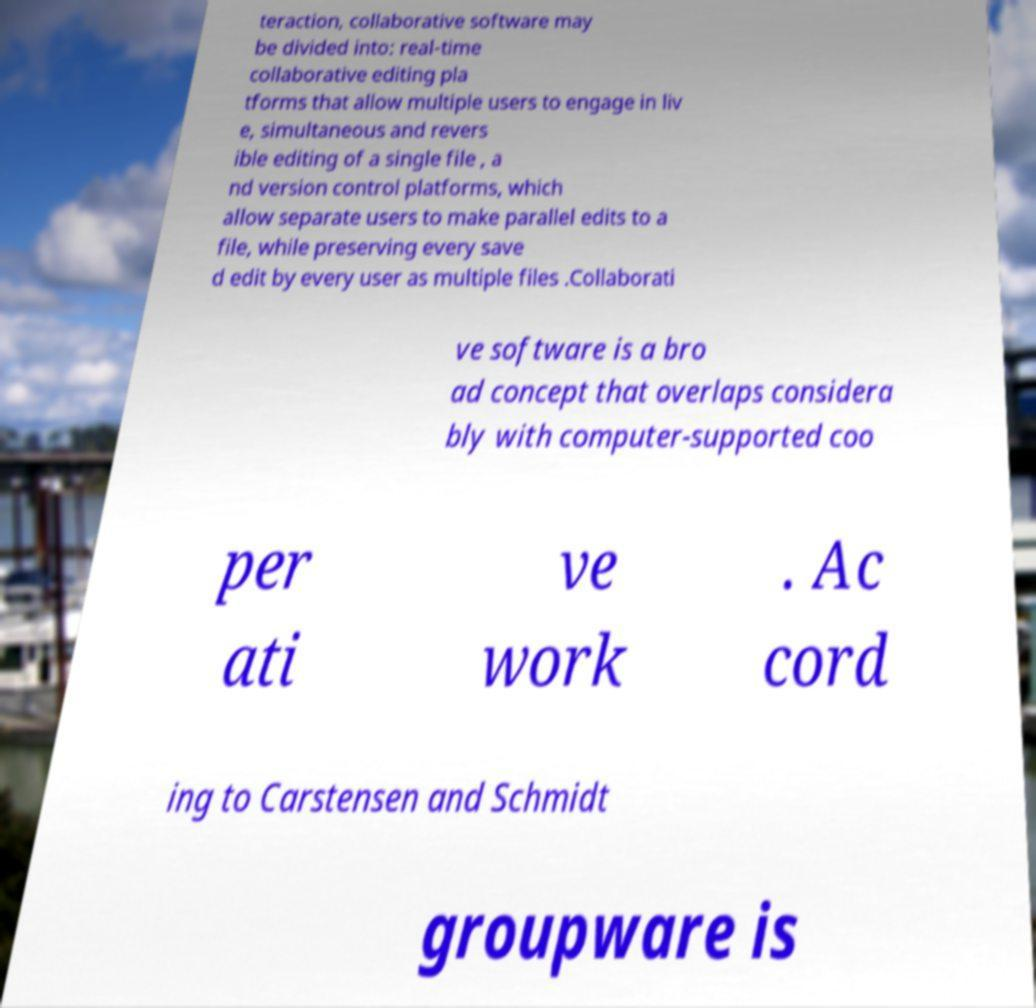Could you extract and type out the text from this image? teraction, collaborative software may be divided into: real-time collaborative editing pla tforms that allow multiple users to engage in liv e, simultaneous and revers ible editing of a single file , a nd version control platforms, which allow separate users to make parallel edits to a file, while preserving every save d edit by every user as multiple files .Collaborati ve software is a bro ad concept that overlaps considera bly with computer-supported coo per ati ve work . Ac cord ing to Carstensen and Schmidt groupware is 